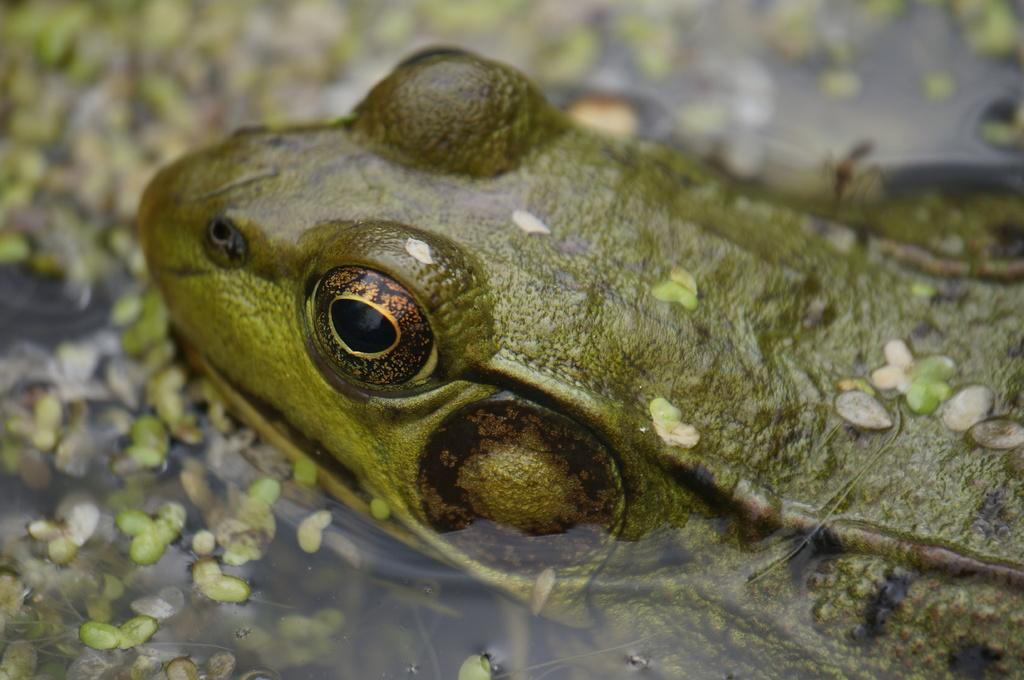What type of animal is present in the image? There is a frog in the image. How is the frog positioned in the image? The frog is truncated towards the right side of the image. What other living organisms can be seen in the image? There are plants in the image. How are the plants depicted in the image? The plants are truncated. What natural element is visible in the image? There is water in the image. How is the water represented in the image? The water is truncated. What brand of toothpaste is being used by the frog in the image? There is no toothpaste present in the image, and the frog is not using any toothpaste. How many scissors can be seen in the image? There are no scissors present in the image. 